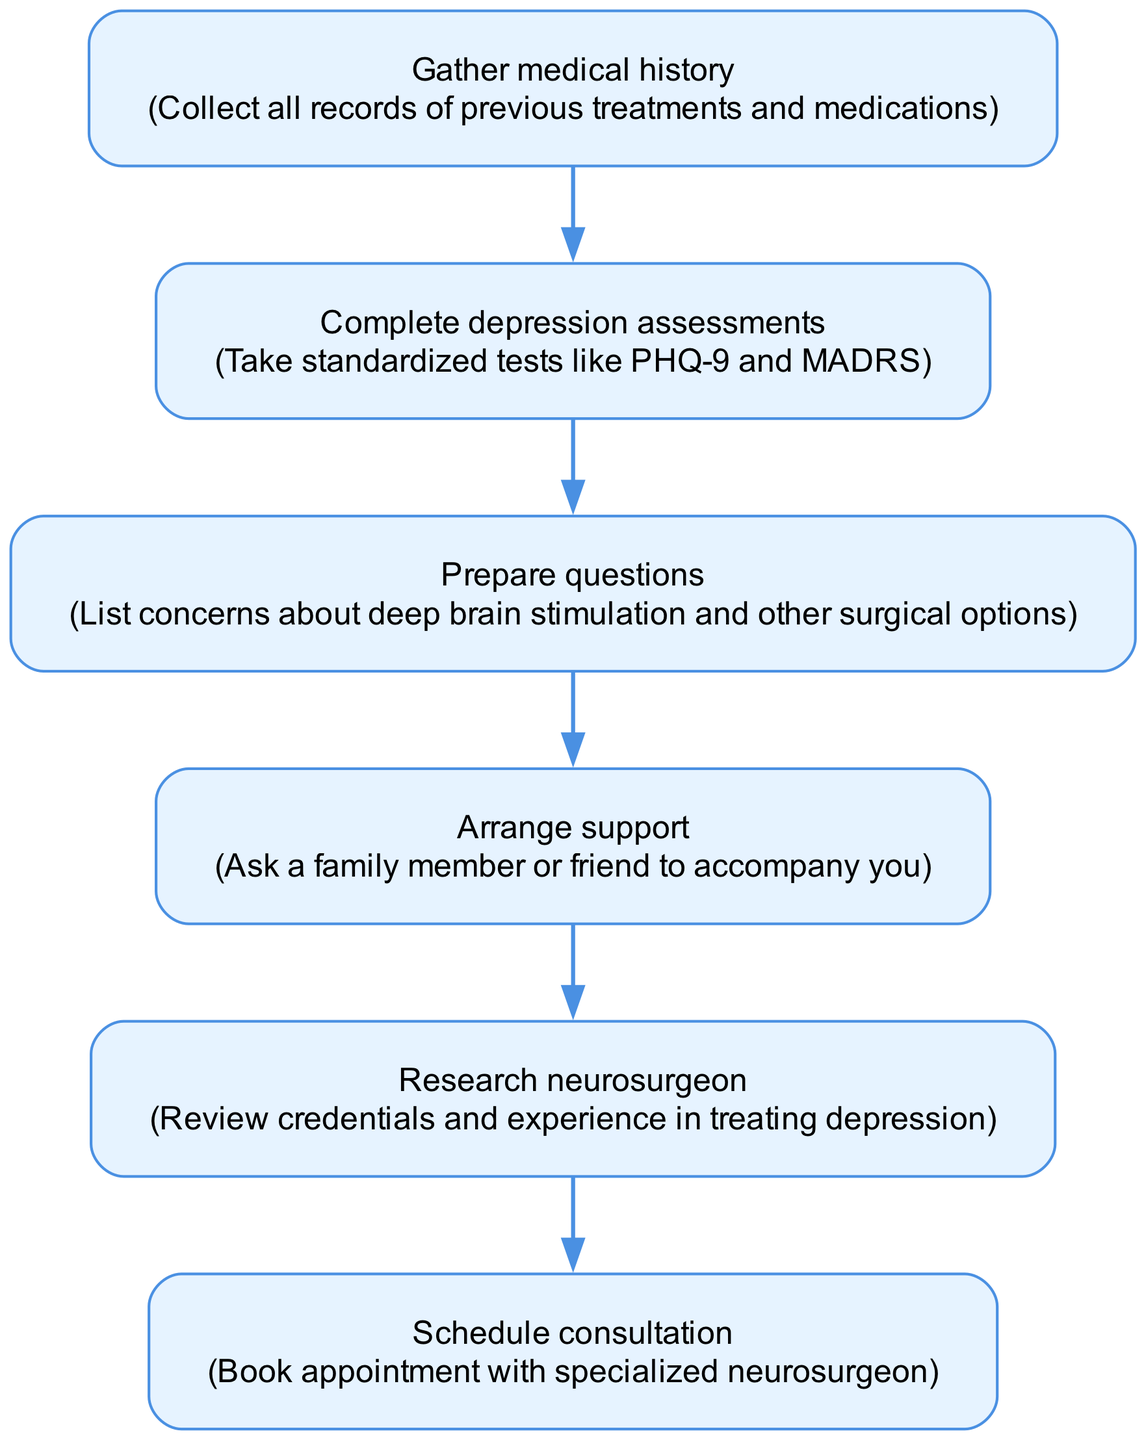What is the first step in preparing for a neurosurgical consultation? The first step mentioned in the diagram is to "Gather medical history." It is listed at the top of the flowchart, indicating it is the initial action to take.
Answer: Gather medical history How many steps are in the flowchart? The flowchart contains six distinct steps, as indicated by the six different nodes labeled from "1" to "6."
Answer: 6 What is the last step before scheduling the consultation? The last step before "Schedule consultation" is "Research neurosurgeon." This indicates that researching the neurosurgeon's background is necessary before making the appointment.
Answer: Research neurosurgeon Which step involves asking a family member or friend for help? The step that involves seeking support from a family member or friend is "Arrange support." This is crucial for having someone accompany you during the consultation.
Answer: Arrange support What assessment tools should be completed in step two? In step two, the assessment tools indicated are standardized tests like PHQ-9 and MADRS. These assessments are important for evaluating the severity of depression.
Answer: PHQ-9 and MADRS If you complete the first three steps, what will be the next step? After completing the first three steps—Gather medical history, Complete depression assessments, and Prepare questions—the next step in the flowchart is to "Arrange support." Thus, this is the next required action.
Answer: Arrange support What type of questions should be prepared for the consultation? The questions to prepare involve concerns about deep brain stimulation and other surgical options, as stated in the relevant step. These are crucial for addressing personal concerns.
Answer: Concerns about deep brain stimulation and other surgical options What action comes immediately after completing depression assessments? Immediately following the completion of depression assessments, the next action is to "Prepare questions." This indicates that assessment results should guide the questions you create for the consultation.
Answer: Prepare questions 